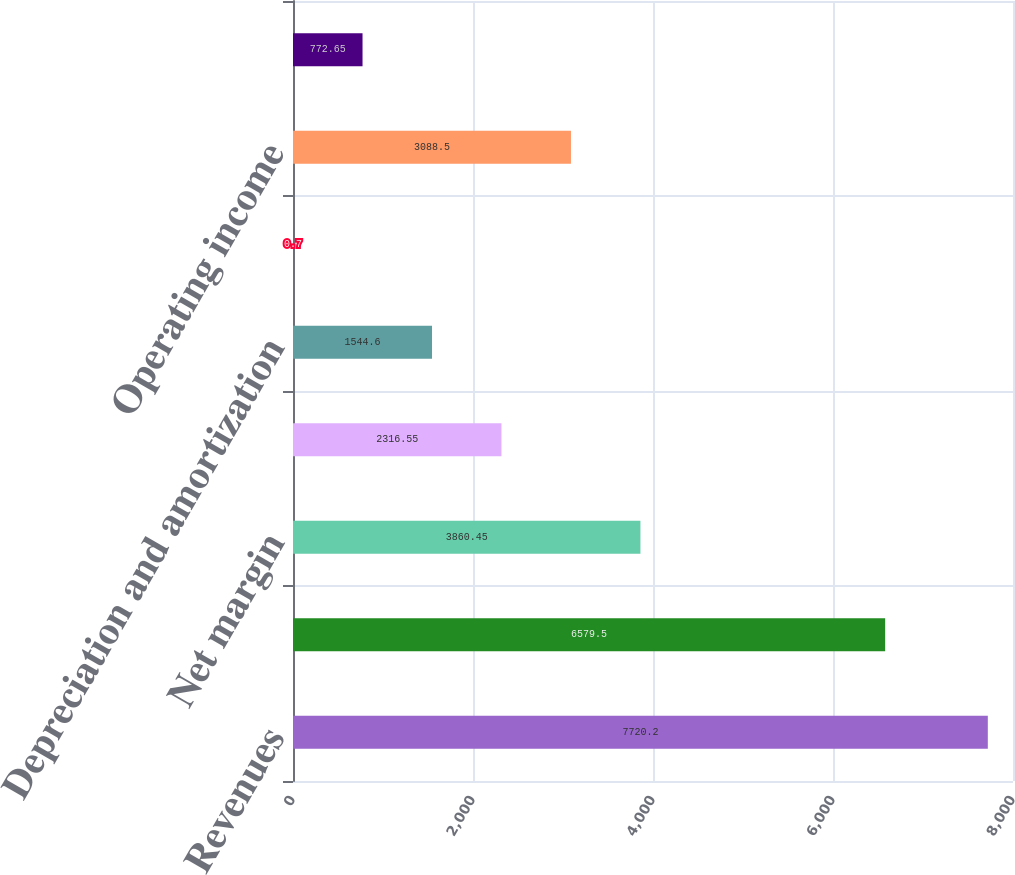Convert chart. <chart><loc_0><loc_0><loc_500><loc_500><bar_chart><fcel>Revenues<fcel>Cost of sales and fuel<fcel>Net margin<fcel>Operating costs<fcel>Depreciation and amortization<fcel>Gain on sale of assets<fcel>Operating income<fcel>Equity earnings from<nl><fcel>7720.2<fcel>6579.5<fcel>3860.45<fcel>2316.55<fcel>1544.6<fcel>0.7<fcel>3088.5<fcel>772.65<nl></chart> 